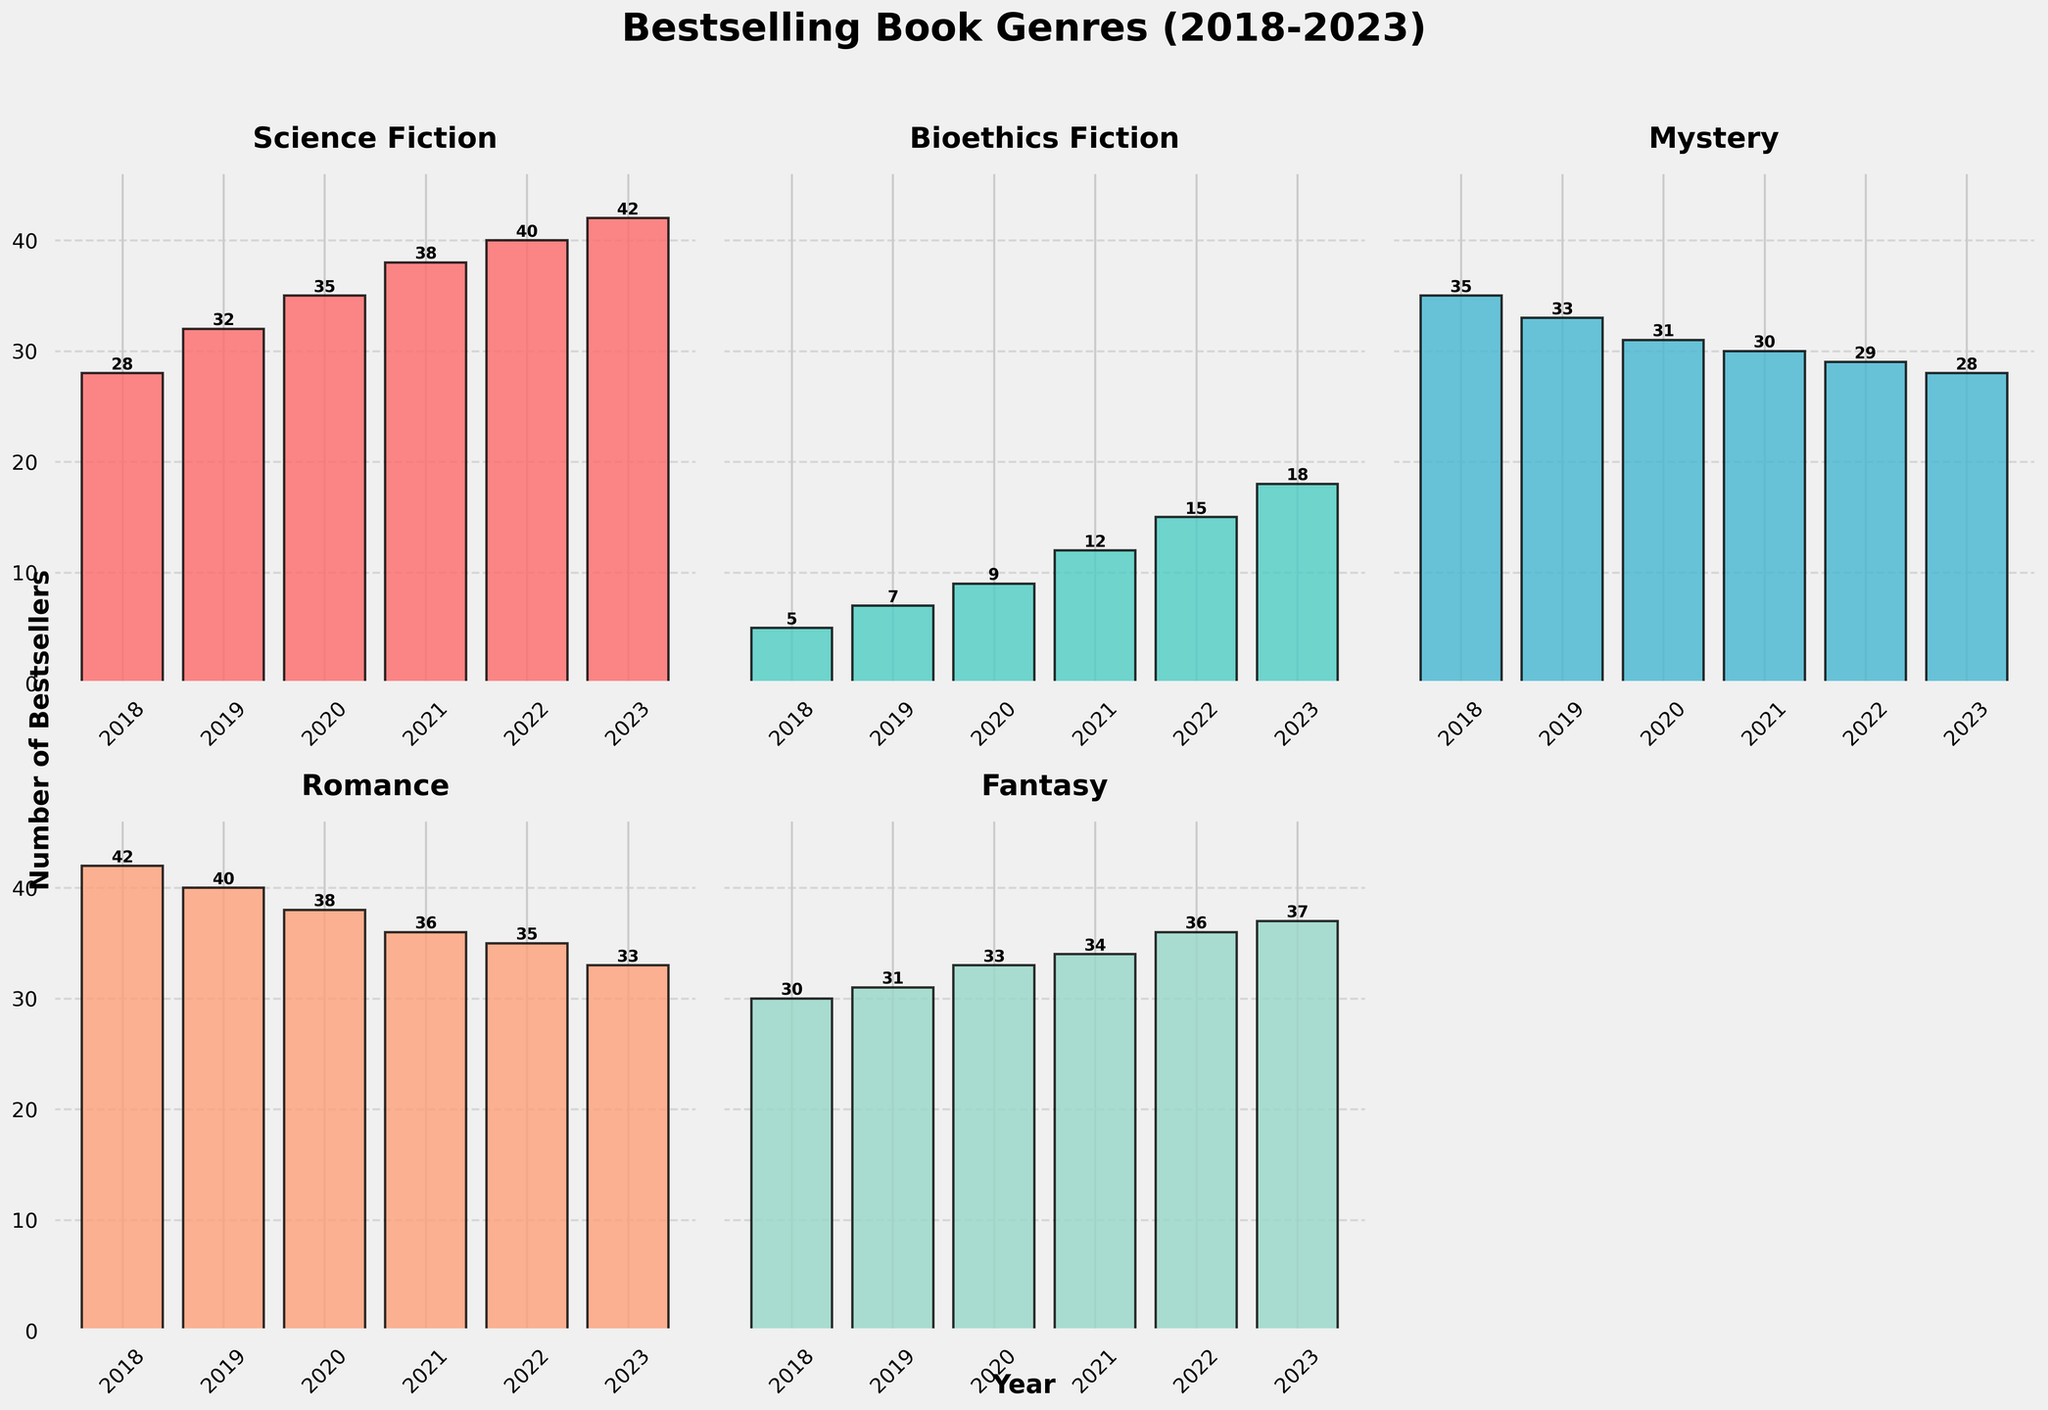What genre saw the highest increase in bestsellers from 2018 to 2023? To determine this, we need to calculate the difference in the number of bestsellers for each genre between 2023 and 2018. The differences are: Science Fiction (42-28=14), Bioethics Fiction (18-5=13), Mystery (28-35=-7), Romance (33-42=-9), Fantasy (37-30=7). Science Fiction has the highest increase with 14 more bestsellers.
Answer: Science Fiction Between 2021 and 2023, which genre had the greatest percentage growth in bestsellers? First, calculate the percentage growth for each genre by comparing 2023 values to 2021 values. Percentage growth = ((Value in 2023 - Value in 2021) / Value in 2021) * 100. Science Fiction: ((42-38)/38) * 100 ≈ 10.53%, Bioethics Fiction: ((18-12)/12) * 100 ≈ 50%, Mystery: ((28-30)/30) * 100 ≈ -6.67%, Romance: ((33-36)/36) * 100 ≈ -8.33%, Fantasy: ((37-34)/34) * 100 ≈ 8.82%. Bioethics Fiction has the greatest percentage growth at approximately 50%.
Answer: Bioethics Fiction How many years did Science Fiction have more bestsellers than Fantasy? By comparing the yearly values for Science Fiction and Fantasy: 2018 (28 vs 30), 2019 (32 vs 31), 2020 (35 vs 33), 2021 (38 vs 34), 2022 (40 vs 36), 2023 (42 vs 37), Science Fiction had more bestsellers than Fantasy in 2019, 2020, 2021, 2022, and 2023 - that's 5 years.
Answer: 5 years Which genre had the least number of bestsellers every year from 2018 to 2023? By examining the yearly values for each genre: 2018 (Bioethics Fiction: 5), 2019 (Bioethics Fiction: 7), 2020 (Bioethics Fiction: 9), 2021 (Bioethics Fiction: 12), 2022 (Bioethics Fiction: 15), 2023 (Bioethics Fiction: 18), Bioethics Fiction had the least number of bestsellers in all the years.
Answer: Bioethics Fiction What is the overall trend for Bioethics Fiction bestsellers from 2018 to 2023? Observing the values from 2018 to 2023 for Bioethics Fiction (5, 7, 9, 12, 15, 18), there is a steady increase every year, indicating a positive growth trend.
Answer: Increasing 